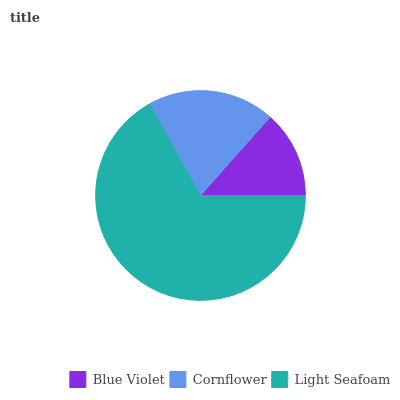Is Blue Violet the minimum?
Answer yes or no. Yes. Is Light Seafoam the maximum?
Answer yes or no. Yes. Is Cornflower the minimum?
Answer yes or no. No. Is Cornflower the maximum?
Answer yes or no. No. Is Cornflower greater than Blue Violet?
Answer yes or no. Yes. Is Blue Violet less than Cornflower?
Answer yes or no. Yes. Is Blue Violet greater than Cornflower?
Answer yes or no. No. Is Cornflower less than Blue Violet?
Answer yes or no. No. Is Cornflower the high median?
Answer yes or no. Yes. Is Cornflower the low median?
Answer yes or no. Yes. Is Light Seafoam the high median?
Answer yes or no. No. Is Light Seafoam the low median?
Answer yes or no. No. 